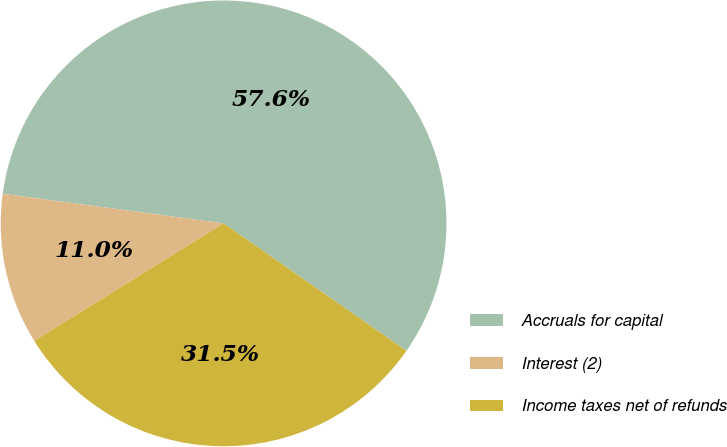Convert chart. <chart><loc_0><loc_0><loc_500><loc_500><pie_chart><fcel>Accruals for capital<fcel>Interest (2)<fcel>Income taxes net of refunds<nl><fcel>57.57%<fcel>10.96%<fcel>31.47%<nl></chart> 